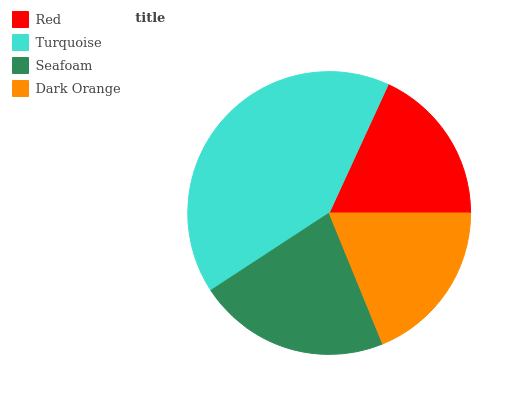Is Red the minimum?
Answer yes or no. Yes. Is Turquoise the maximum?
Answer yes or no. Yes. Is Seafoam the minimum?
Answer yes or no. No. Is Seafoam the maximum?
Answer yes or no. No. Is Turquoise greater than Seafoam?
Answer yes or no. Yes. Is Seafoam less than Turquoise?
Answer yes or no. Yes. Is Seafoam greater than Turquoise?
Answer yes or no. No. Is Turquoise less than Seafoam?
Answer yes or no. No. Is Seafoam the high median?
Answer yes or no. Yes. Is Dark Orange the low median?
Answer yes or no. Yes. Is Turquoise the high median?
Answer yes or no. No. Is Red the low median?
Answer yes or no. No. 